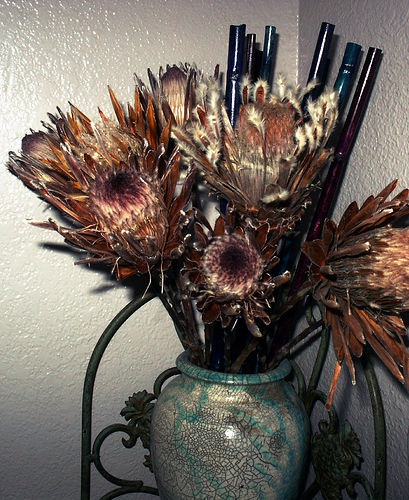Describe the objects in this image and their specific colors. I can see potted plant in gray, black, and maroon tones, chair in gray, black, darkgray, and lightgray tones, and vase in gray, black, darkgray, and teal tones in this image. 